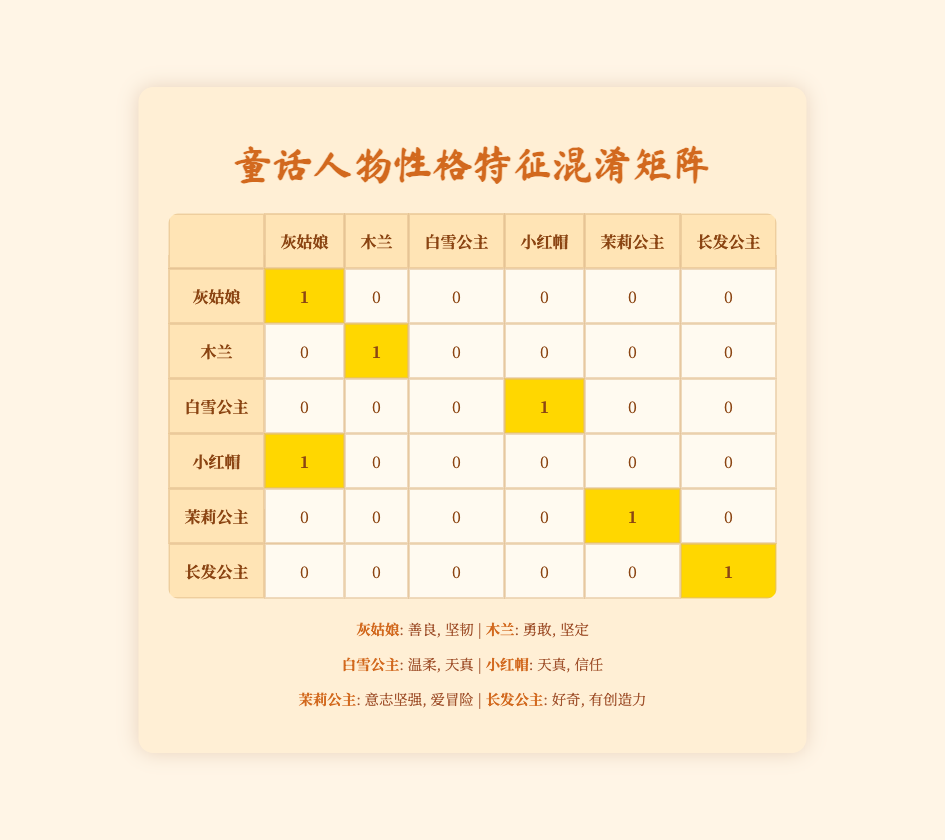What character was predicted as Snow White? Snow White was predicted as Little Red Riding Hood. By looking at the row for Snow White, we can see that the prediction made for her was "innocent, trusting."
Answer: Little Red Riding Hood How many characters were correctly predicted in total? By inspecting each row of the confusion matrix, we find that Cinderella, Mulan, Jasmine, and Rapunzel were all predicted correctly, totaling 4 correct predictions.
Answer: 4 Was Little Red Riding Hood incorrectly predicted? Yes, Little Red Riding Hood was predicted as Cinderella instead of being accurately identified. This can be verified by looking at the respective row and column for Little Red Riding Hood which shows a mismatch.
Answer: Yes Which characters were correctly predicted? The correctly predicted characters are Cinderella, Mulan, Jasmine, and Rapunzel. Focusing on the table, these characters have highlighted (1) values, showing correct predictions.
Answer: Cinderella, Mulan, Jasmine, Rapunzel What is the total number of predictions made for Snow White? Snow White has one prediction made, and since it was "innocent, trusting," which is incorrectly aligned with her actual traits, we assess one row corresponding to her to determine the count.
Answer: 1 How many characters had matching actual and predicted traits? The characters with matching actual and predicted traits are Cinderella, Mulan, Jasmine, and Rapunzel, summing up to 4, indicating that those predictions match their traits perfectly.
Answer: 4 Is there any character that was predicted correctly but not listed as such in their traits? No, all characters that were predicted correctly are listed properly with their traits. Checking the table confirms that each match aligns with the traits they possess.
Answer: No Which characters have the same traits and were both predicted accurately? The characters that have the same traits and were predicted accurately are Cinderella, Mulan, Jasmine, and Rapunzel, as seen by examining the appropriate rows where predictions match the traits listed.
Answer: Cinderella, Mulan, Jasmine, Rapunzel 